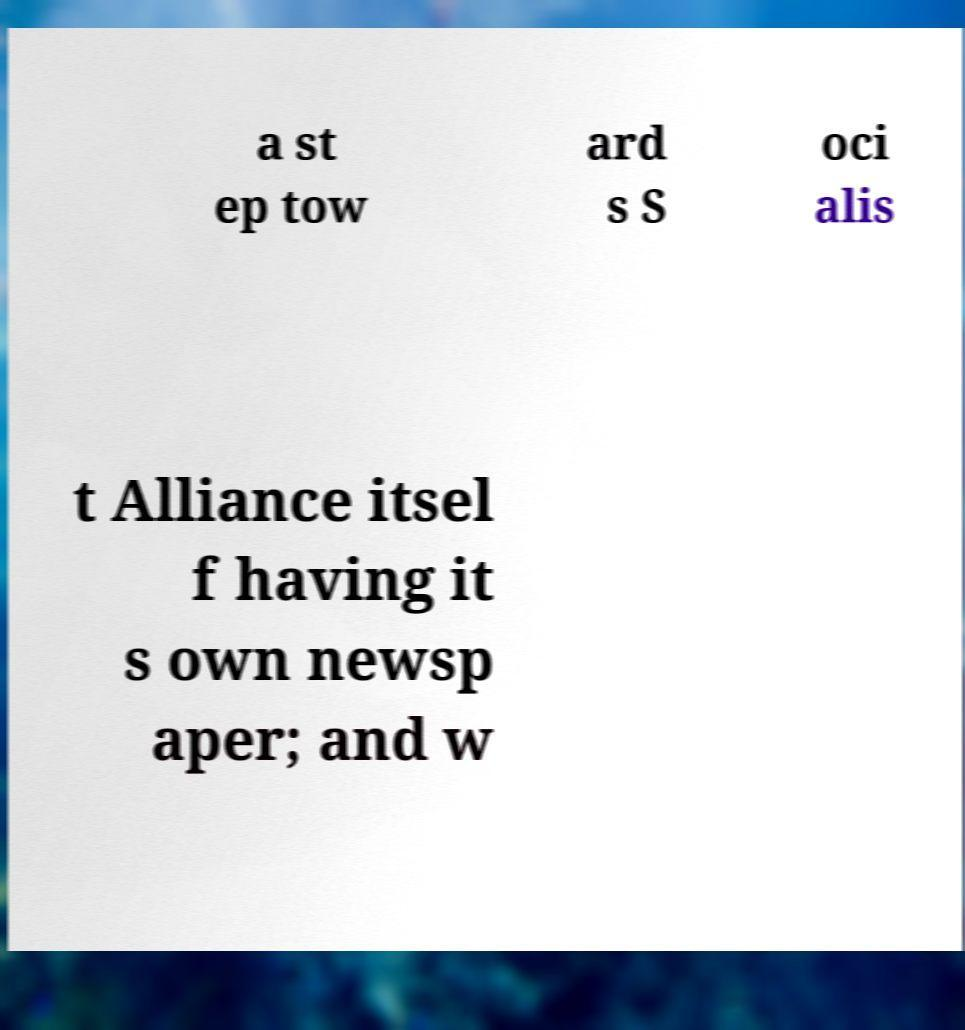For documentation purposes, I need the text within this image transcribed. Could you provide that? a st ep tow ard s S oci alis t Alliance itsel f having it s own newsp aper; and w 